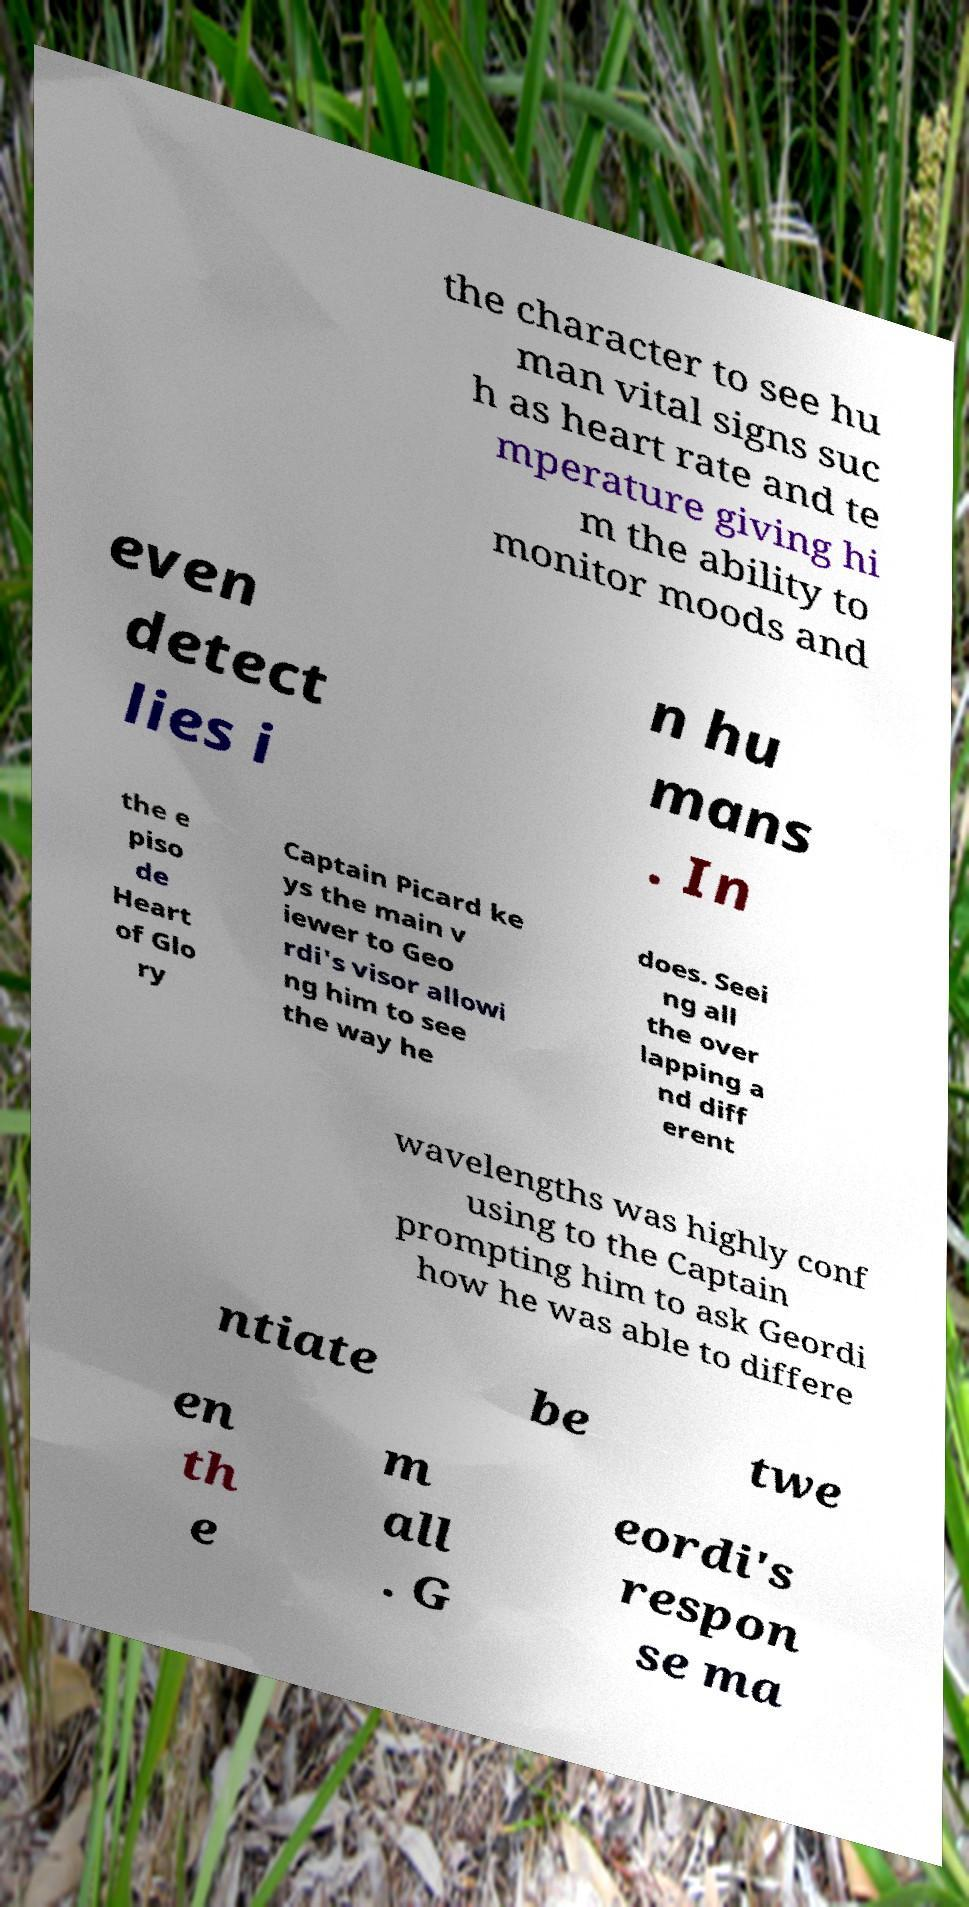Please identify and transcribe the text found in this image. the character to see hu man vital signs suc h as heart rate and te mperature giving hi m the ability to monitor moods and even detect lies i n hu mans . In the e piso de Heart of Glo ry Captain Picard ke ys the main v iewer to Geo rdi's visor allowi ng him to see the way he does. Seei ng all the over lapping a nd diff erent wavelengths was highly conf using to the Captain prompting him to ask Geordi how he was able to differe ntiate be twe en th e m all . G eordi's respon se ma 